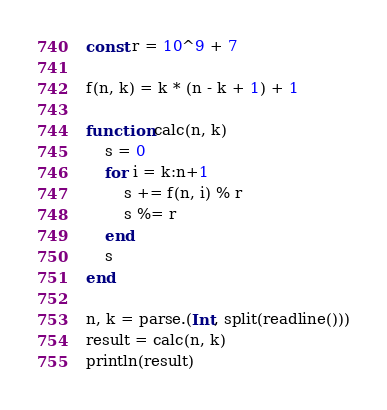<code> <loc_0><loc_0><loc_500><loc_500><_Julia_>const r = 10^9 + 7

f(n, k) = k * (n - k + 1) + 1

function calc(n, k)
    s = 0
    for i = k:n+1
        s += f(n, i) % r
        s %= r
    end
    s
end

n, k = parse.(Int, split(readline()))
result = calc(n, k)
println(result)
</code> 